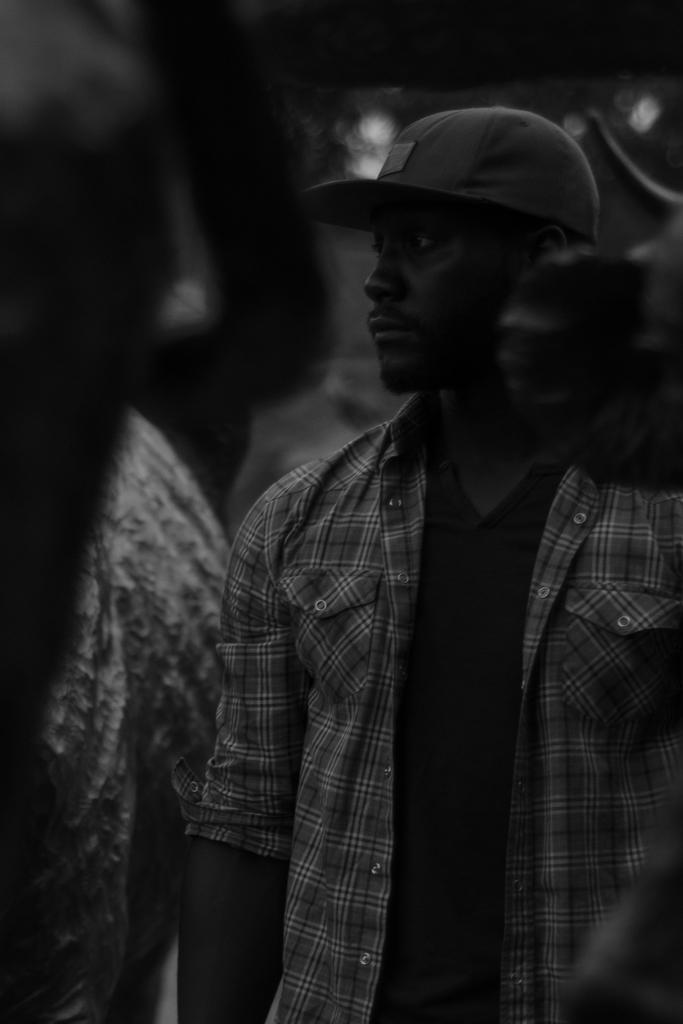How many people are in the image? There are persons in the image. Can you describe the clothing of the person in the foreground? The person in the foreground is wearing a cap. What trick is the person in the background performing in the image? There is no indication of a trick being performed in the image. 